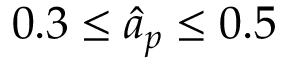Convert formula to latex. <formula><loc_0><loc_0><loc_500><loc_500>0 . 3 \leq \hat { a } _ { p } \leq 0 . 5</formula> 